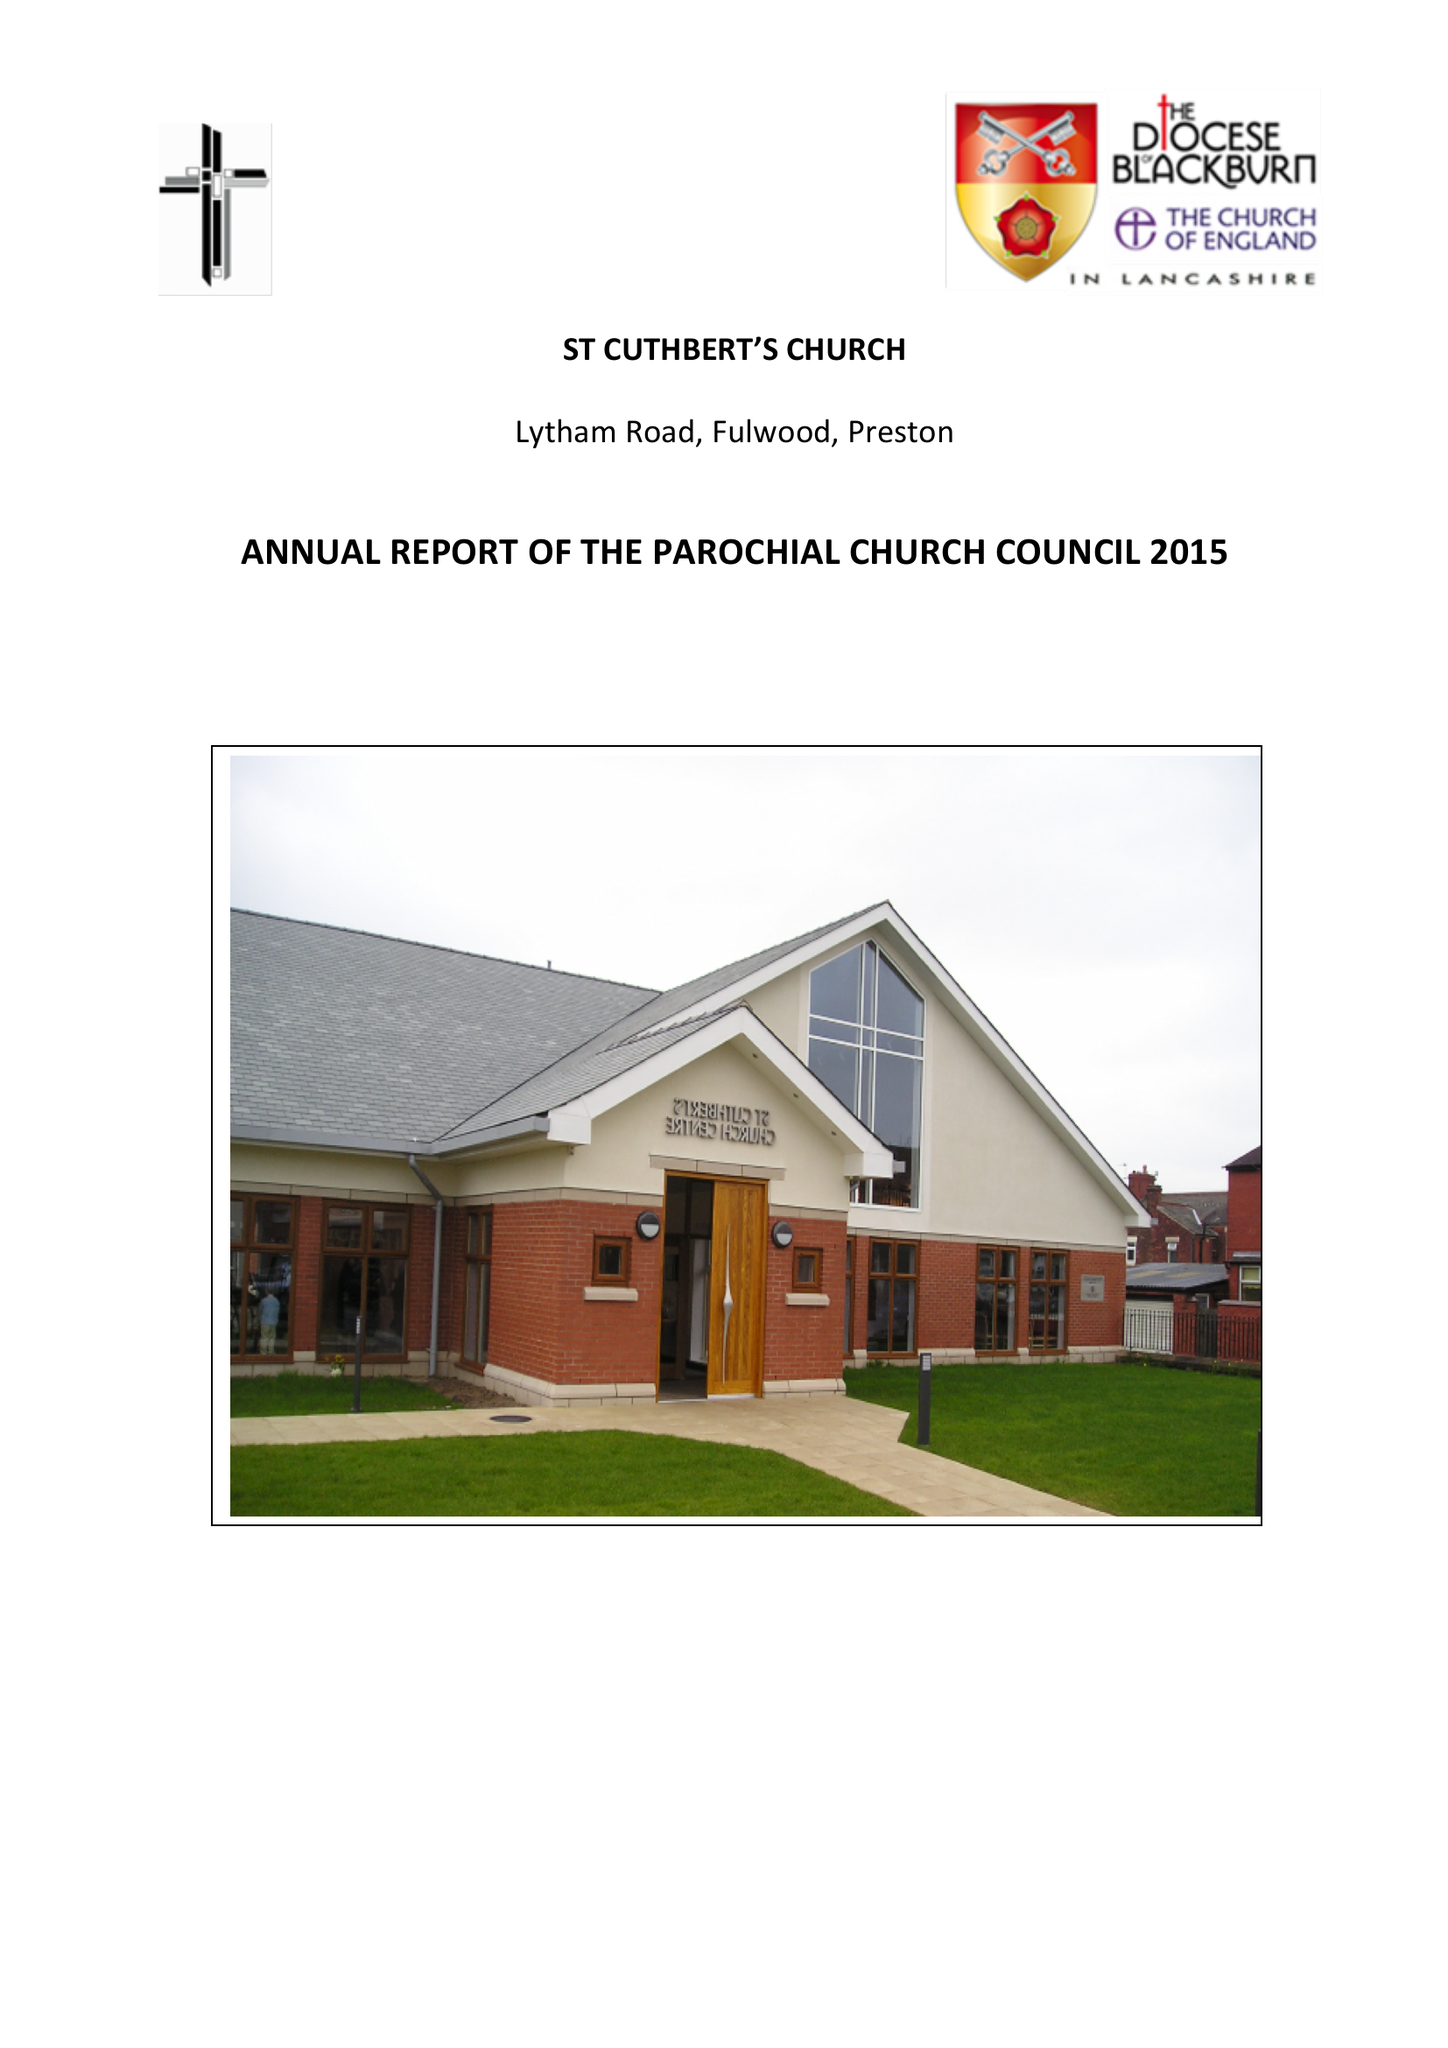What is the value for the income_annually_in_british_pounds?
Answer the question using a single word or phrase. 158359.32 